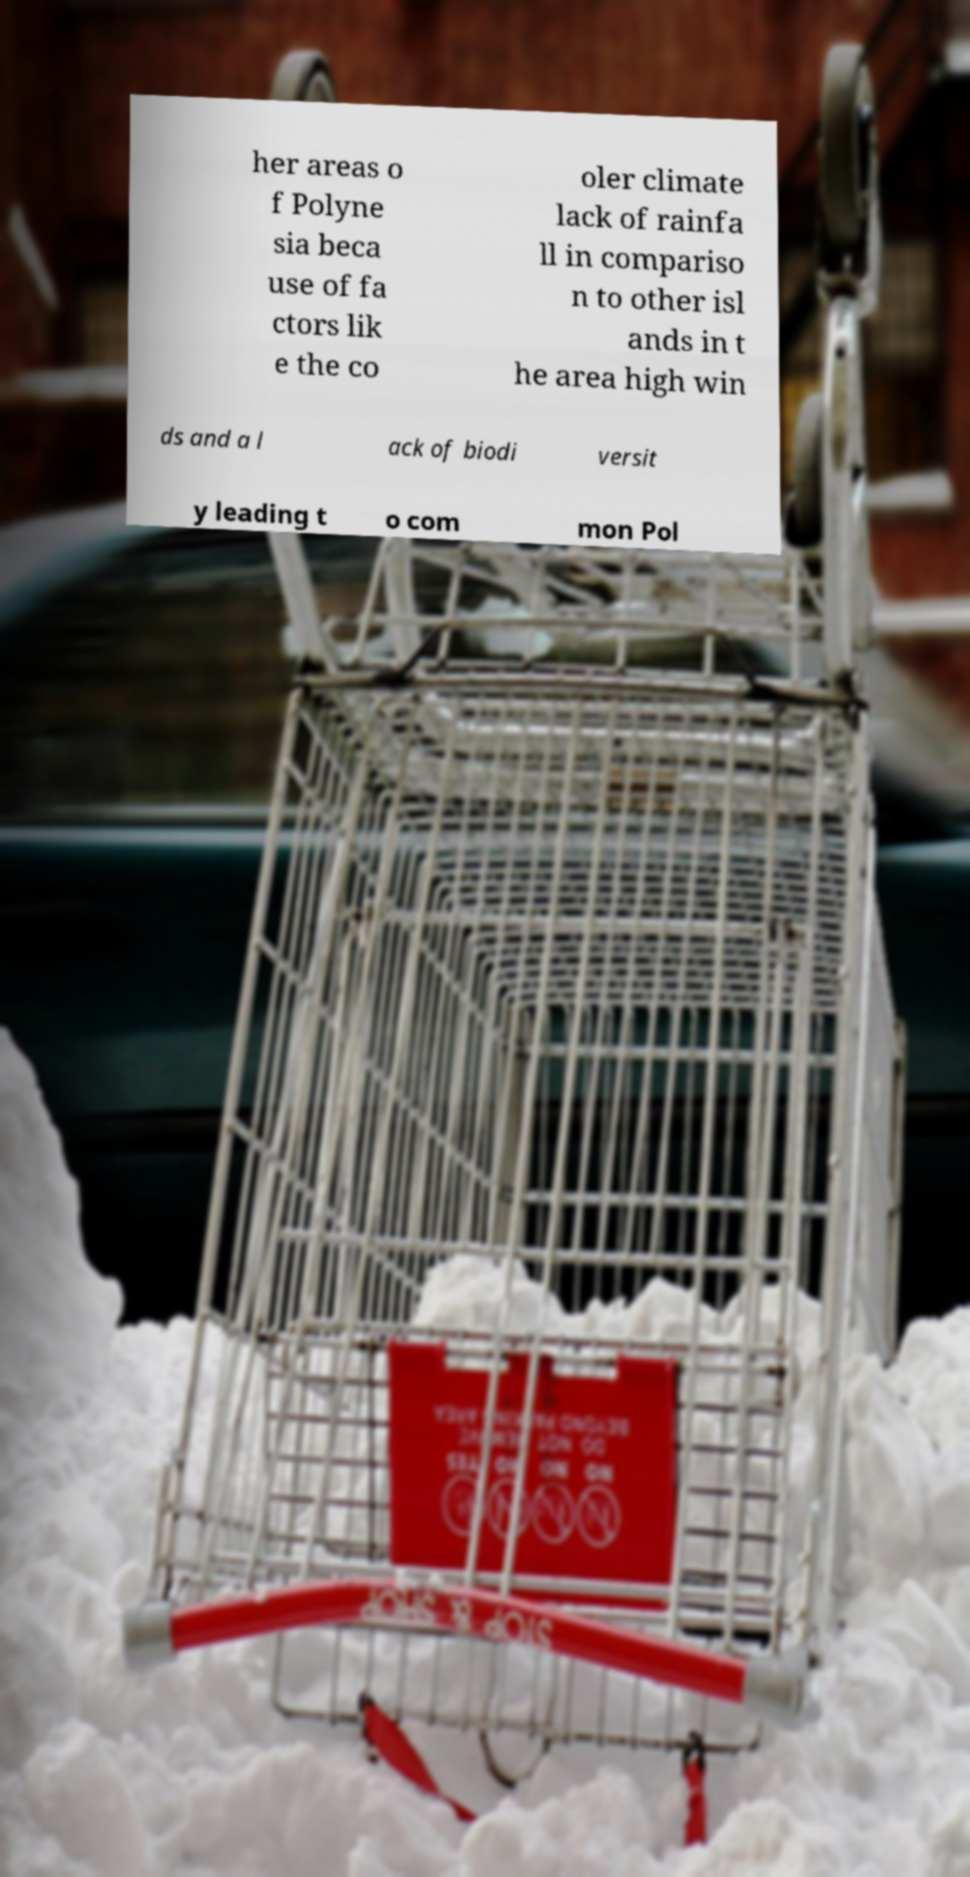Please identify and transcribe the text found in this image. her areas o f Polyne sia beca use of fa ctors lik e the co oler climate lack of rainfa ll in compariso n to other isl ands in t he area high win ds and a l ack of biodi versit y leading t o com mon Pol 